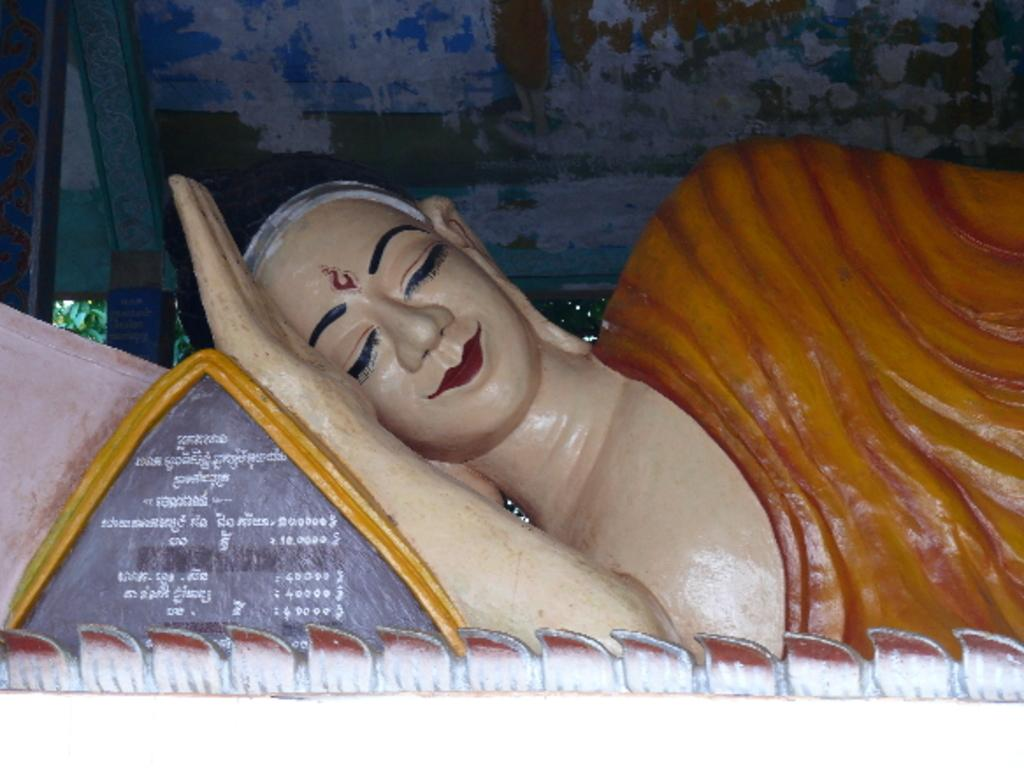What is the main subject in the image? There is a statue in the image. What else can be seen in the image besides the statue? There is text and plants visible in the image. What type of roof is present in the image? There is a metal roof in the image. What type of jelly is being served at the society event in the image? There is no jelly or society event present in the image; it features a statue, text, plants, and a metal roof. Can you describe the facial expression of the statue in the image? The provided facts do not mention any facial expression of the statue, so it cannot be described. 